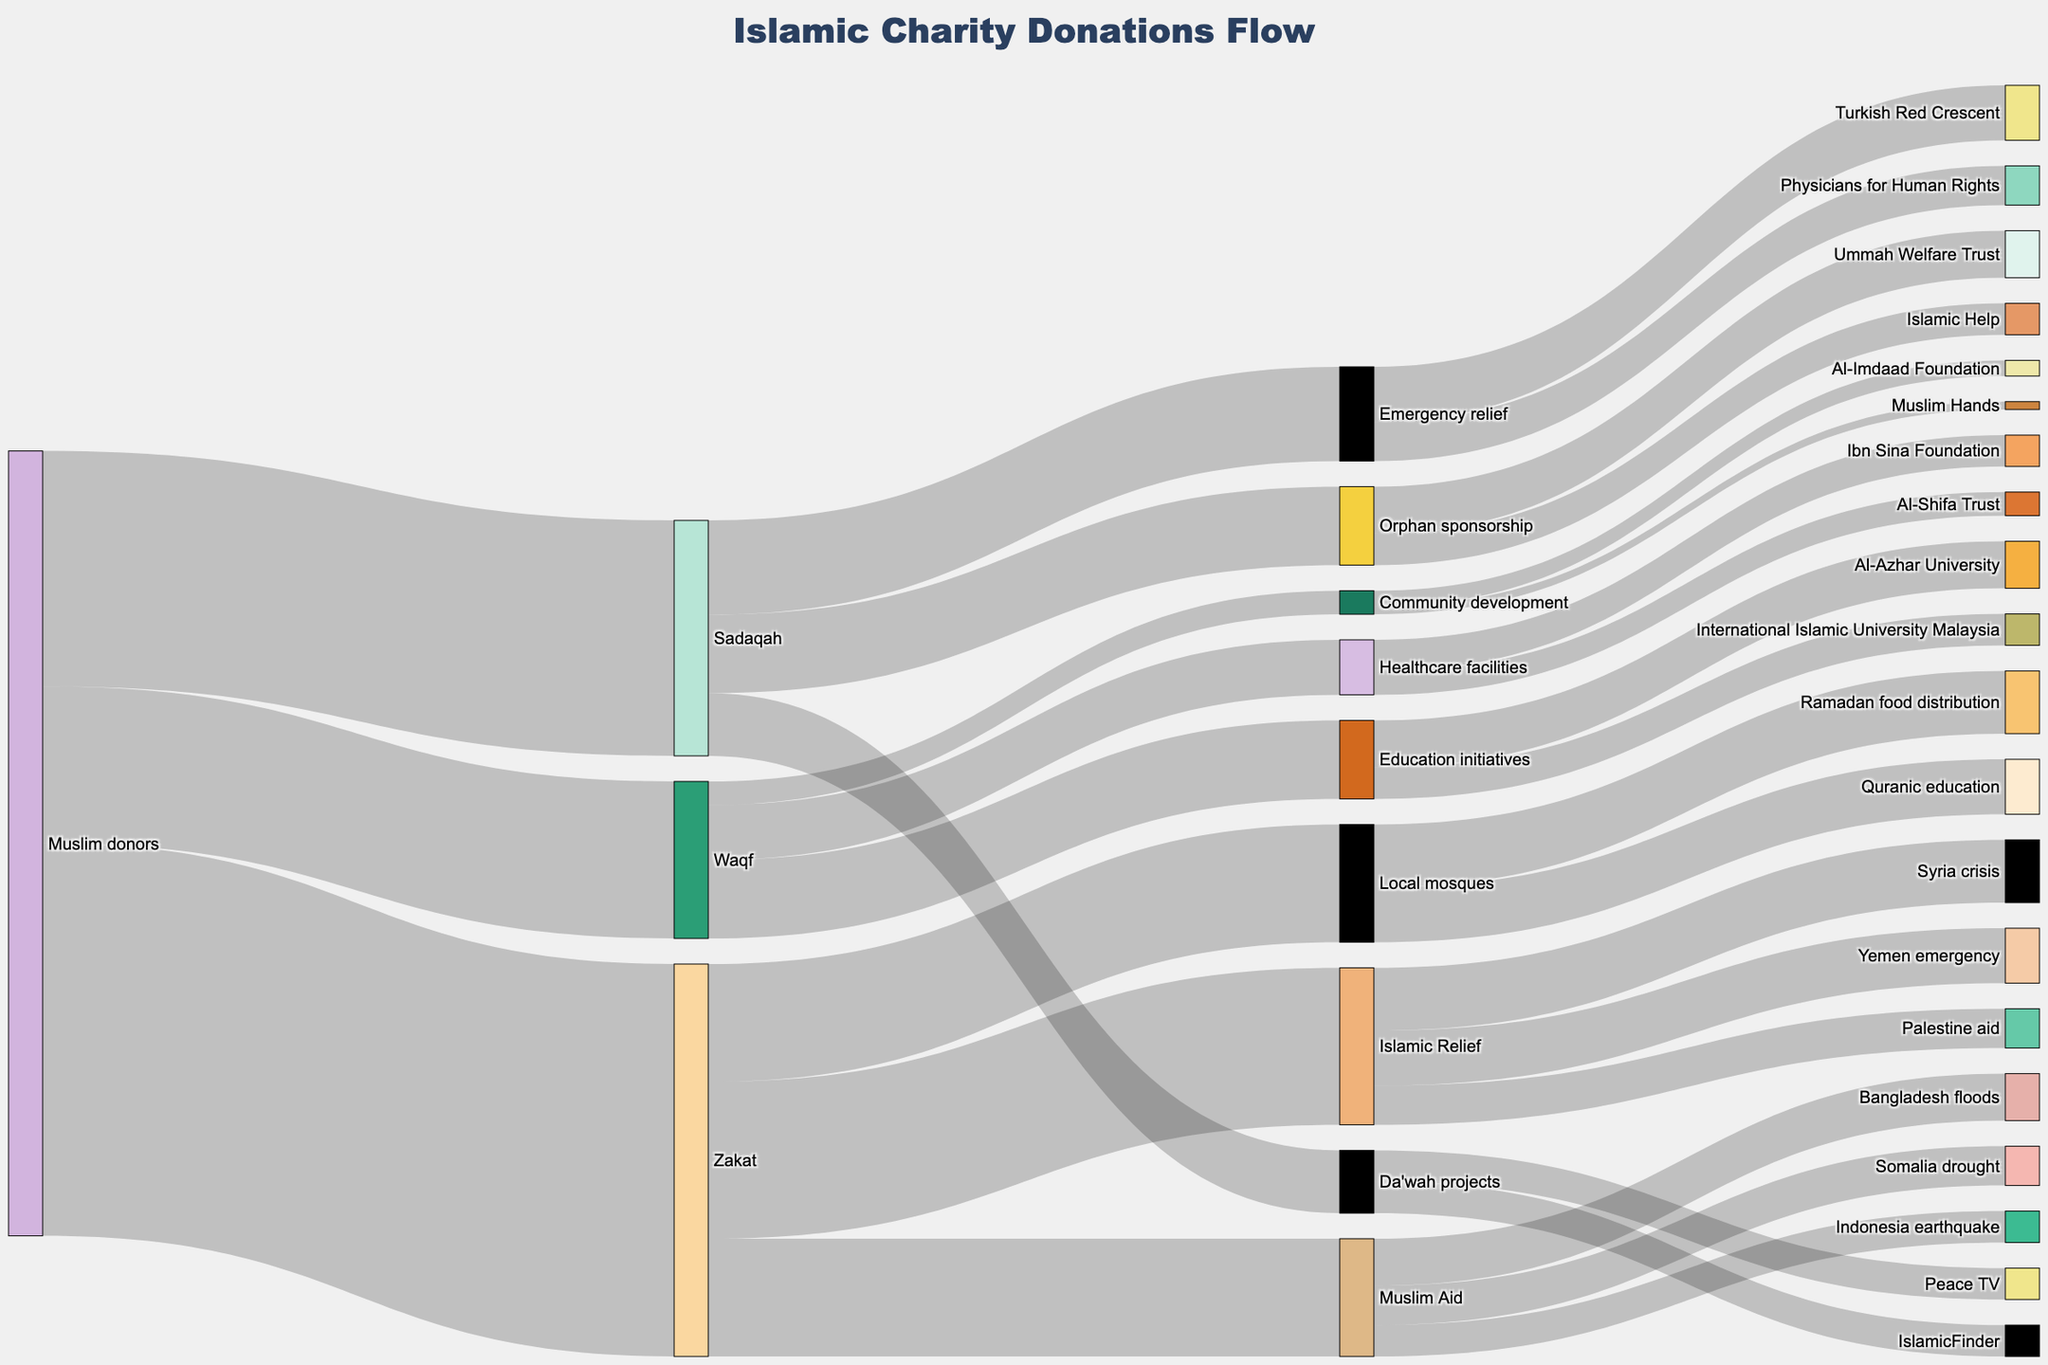what is the total donation that went to all causes? Sum all donation values: 5000000 (Zakat) + 3000000 (Sadaqah) + 2000000 (Waqf) = 10000000
Answer: 10000000 Which organization received the most funds through Zakat? Among the organizations under Zakat: Islamic Relief (2000000), Muslim Aid (1500000), Local mosques (1500000). Islamic Relief received the highest amount.
Answer: Islamic Relief What is the combined donation value to Education initiatives and Healthcare facilities through Waqf? Add values for Education initiatives and Healthcare facilities: 1000000 + 700000 = 1700000
Answer: 1700000 Which received more donations: Sadaqah or Waqf? Compare the donation values: Sadaqah (3000000) vs Waqf (2000000). Sadaqah received more.
Answer: Sadaqah What is the donation value for Community development through Waqf? The amount shown next to Community development through Waqf is 300000.
Answer: 300000 How much did Muslim Aid receive in total? Sum the values under Muslim Aid: Bangladesh floods (600000), Somalia drought (500000), Indonesia earthquake (400000). Total is 1500000.
Answer: 1500000 From the Zakat donations, which categories received an equal amount of funds? Compare the values under Zakat: Muslim Aid and Local mosques both received 1500000 each.
Answer: Muslim Aid and Local mosques How much more did Syria crisis receive compared to Palestine aid through Islamic Relief? Subtract the value for Palestine aid from Syria crisis: 800000 - 500000 = 300000
Answer: 300000 Which category received donations from both Sadaqah and Waqf? There are no categories in the figure that received donations from both Sadaqah and Waqf.
Answer: None What is the total amount donated through Emergency relief under Sadaqah? Sum the values under Emergency relief: Turkish Red Crescent (700000) + Physicians for Human Rights (500000) = 1200000
Answer: 1200000 